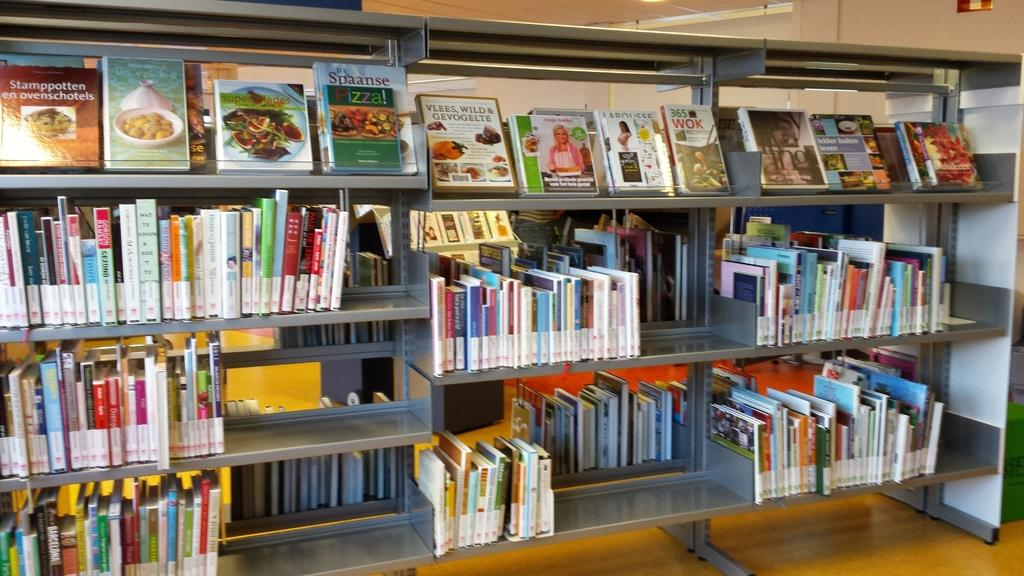<image>
Create a compact narrative representing the image presented. Books on library shelves with cookbooks on the top row including one about Pizza. 